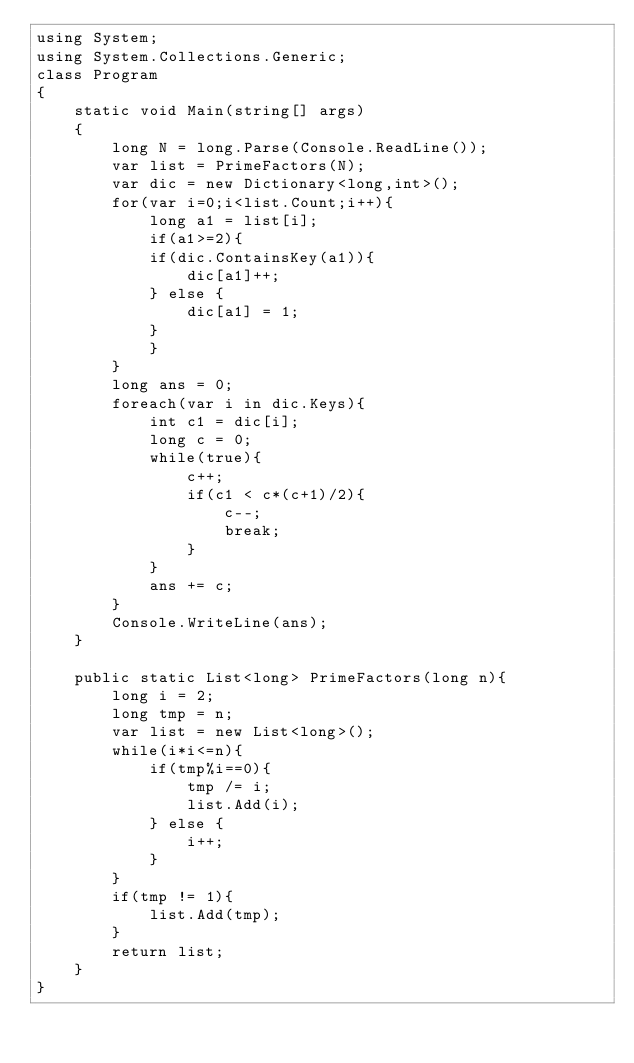<code> <loc_0><loc_0><loc_500><loc_500><_C#_>using System;
using System.Collections.Generic;
class Program
{
	static void Main(string[] args)
	{
		long N = long.Parse(Console.ReadLine());
		var list = PrimeFactors(N);
		var dic = new Dictionary<long,int>();
		for(var i=0;i<list.Count;i++){
			long a1 = list[i];
			if(a1>=2){
			if(dic.ContainsKey(a1)){
				dic[a1]++;
			} else {
				dic[a1] = 1;
			}
			}
		}
		long ans = 0;
		foreach(var i in dic.Keys){
			int c1 = dic[i];
			long c = 0;
			while(true){
				c++;
				if(c1 < c*(c+1)/2){
					c--;
					break;
				}
			}
			ans += c;
		}
		Console.WriteLine(ans);
	}
	
	public static List<long> PrimeFactors(long n){
		long i = 2;
		long tmp = n;
		var list = new List<long>();
		while(i*i<=n){
			if(tmp%i==0){
				tmp /= i;
				list.Add(i);
			} else {
				i++;
			}
		}
		if(tmp != 1){
			list.Add(tmp);
		}
		return list;
	}
}</code> 